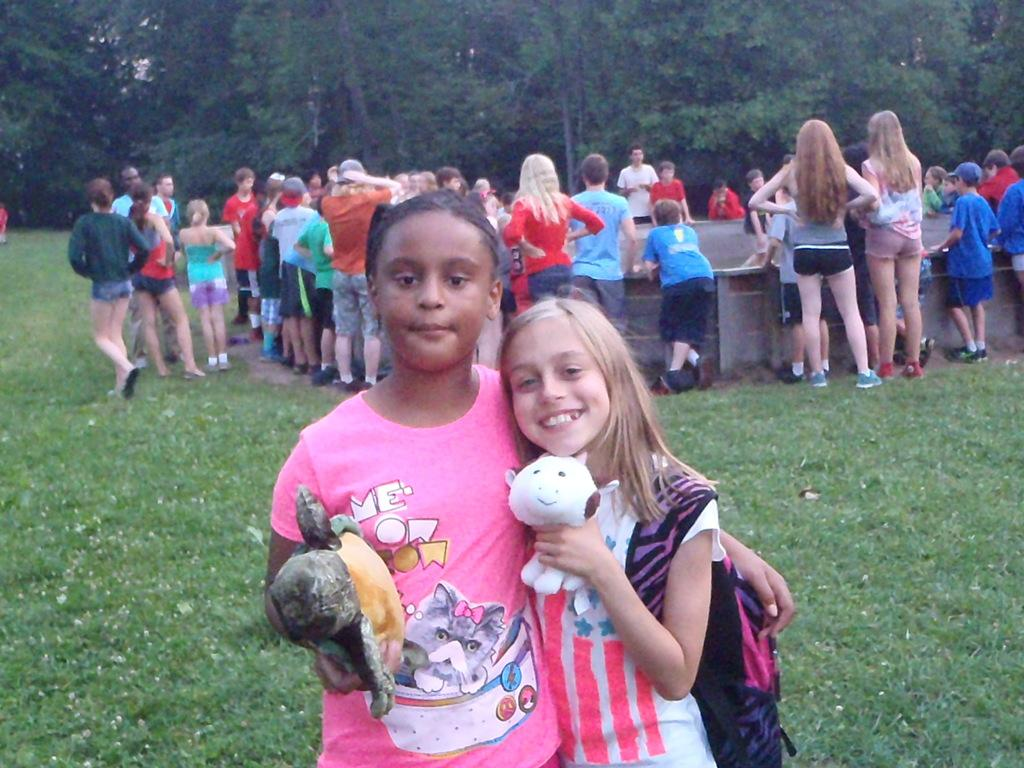What is the primary feature of the land in the image? The land is covered with grass. What are the two girls holding in the image? The two girls are holding toys. Can you describe the background of the image? There are people and trees present in the background. What type of clouds can be seen in the image? There are no clouds visible in the image; the sky is not mentioned in the provided facts. 